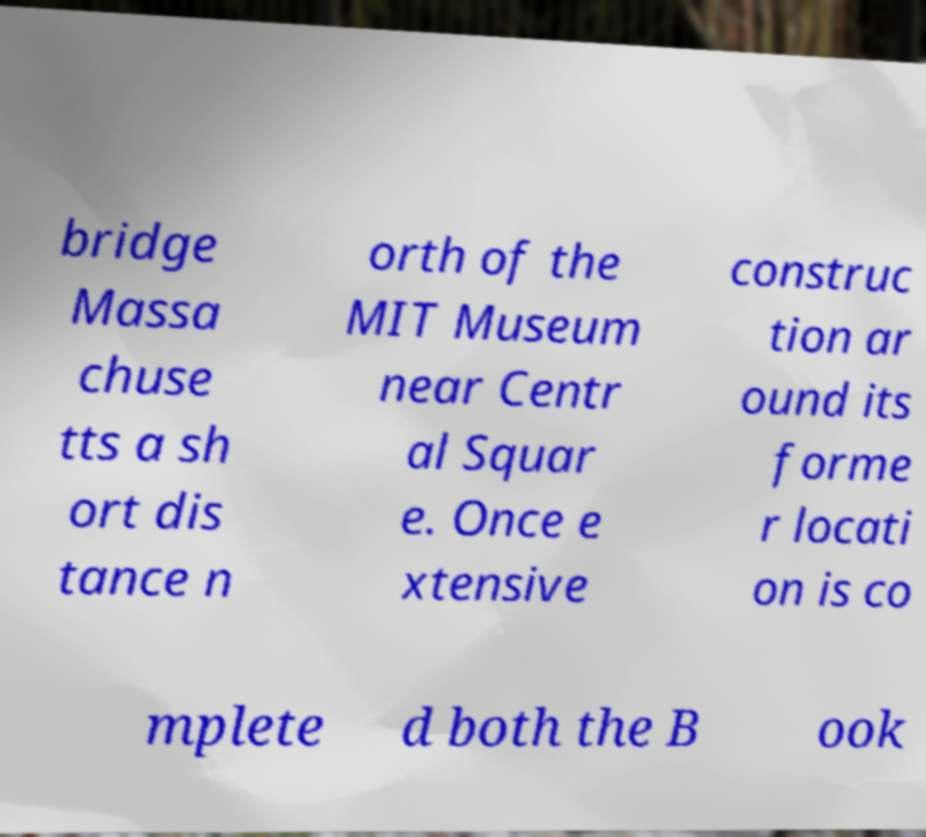Can you read and provide the text displayed in the image?This photo seems to have some interesting text. Can you extract and type it out for me? bridge Massa chuse tts a sh ort dis tance n orth of the MIT Museum near Centr al Squar e. Once e xtensive construc tion ar ound its forme r locati on is co mplete d both the B ook 